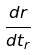Convert formula to latex. <formula><loc_0><loc_0><loc_500><loc_500>\frac { d r } { d t _ { r } }</formula> 